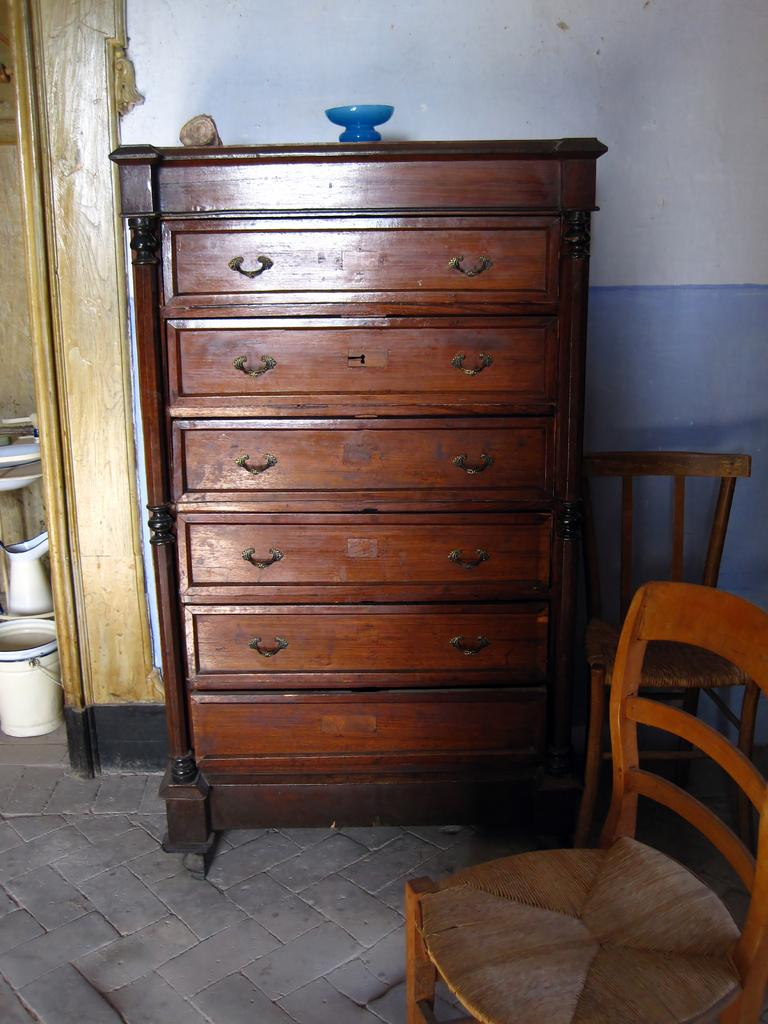What type of furniture is present in the image? There is a wooden shelf in the image. What feature does the shelf have? The shelf has holders. What type of seating is visible in the image? There are chairs in the image. What can be seen in the background of the image? There is a wall in the background of the image. What type of shirt is the fairy wearing in the image? There are no fairies or shirts present in the image. What type of jar is on the shelf in the image? There is no jar present on the shelf in the image. 